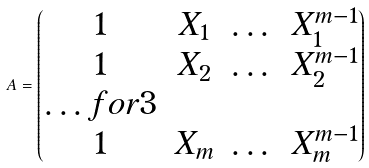<formula> <loc_0><loc_0><loc_500><loc_500>A = \begin{pmatrix} 1 & X _ { 1 } & \dots & X _ { 1 } ^ { m - 1 } \\ 1 & X _ { 2 } & \dots & X _ { 2 } ^ { m - 1 } \\ \hdots f o r { 3 } \\ 1 & X _ { m } & \dots & X _ { m } ^ { m - 1 } \end{pmatrix}</formula> 